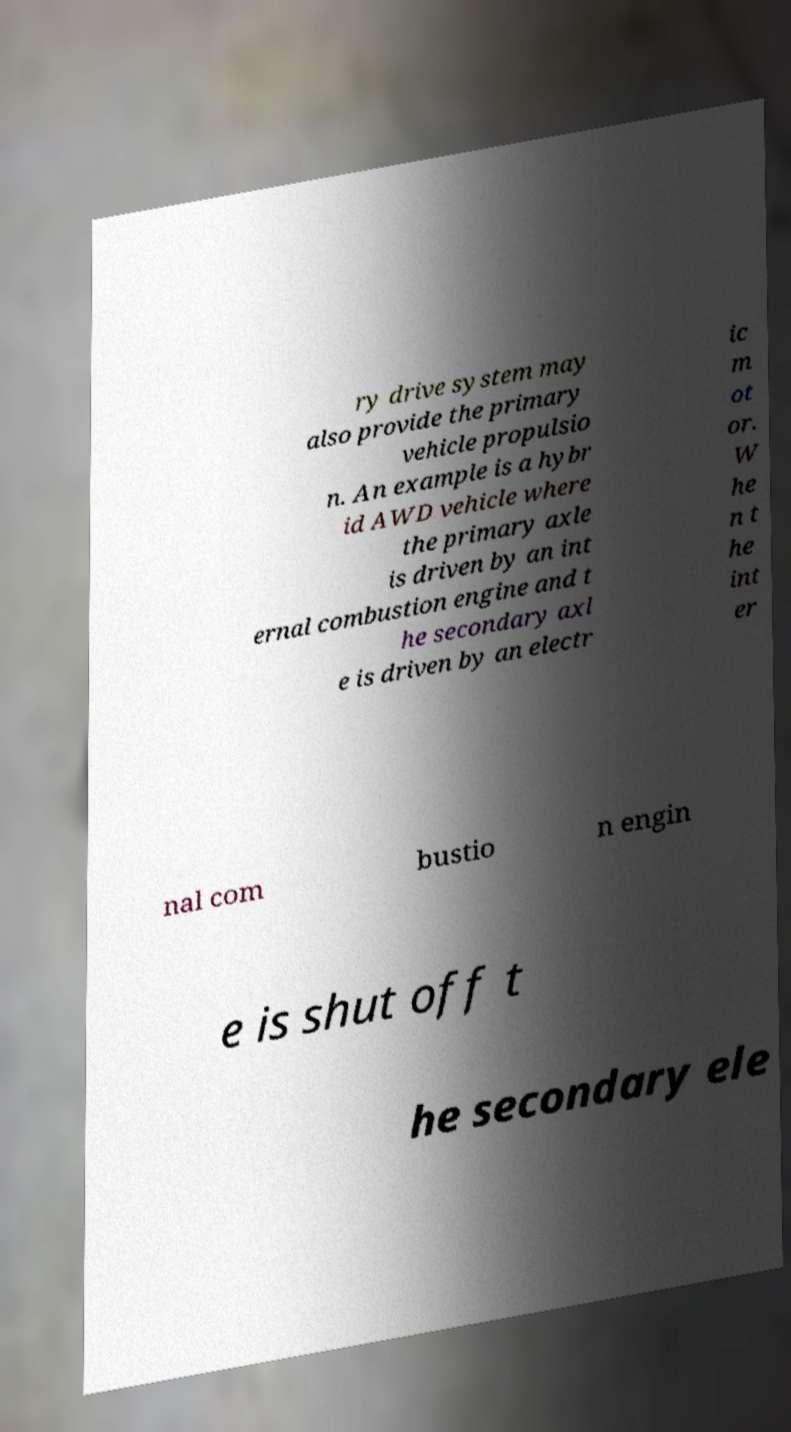I need the written content from this picture converted into text. Can you do that? ry drive system may also provide the primary vehicle propulsio n. An example is a hybr id AWD vehicle where the primary axle is driven by an int ernal combustion engine and t he secondary axl e is driven by an electr ic m ot or. W he n t he int er nal com bustio n engin e is shut off t he secondary ele 